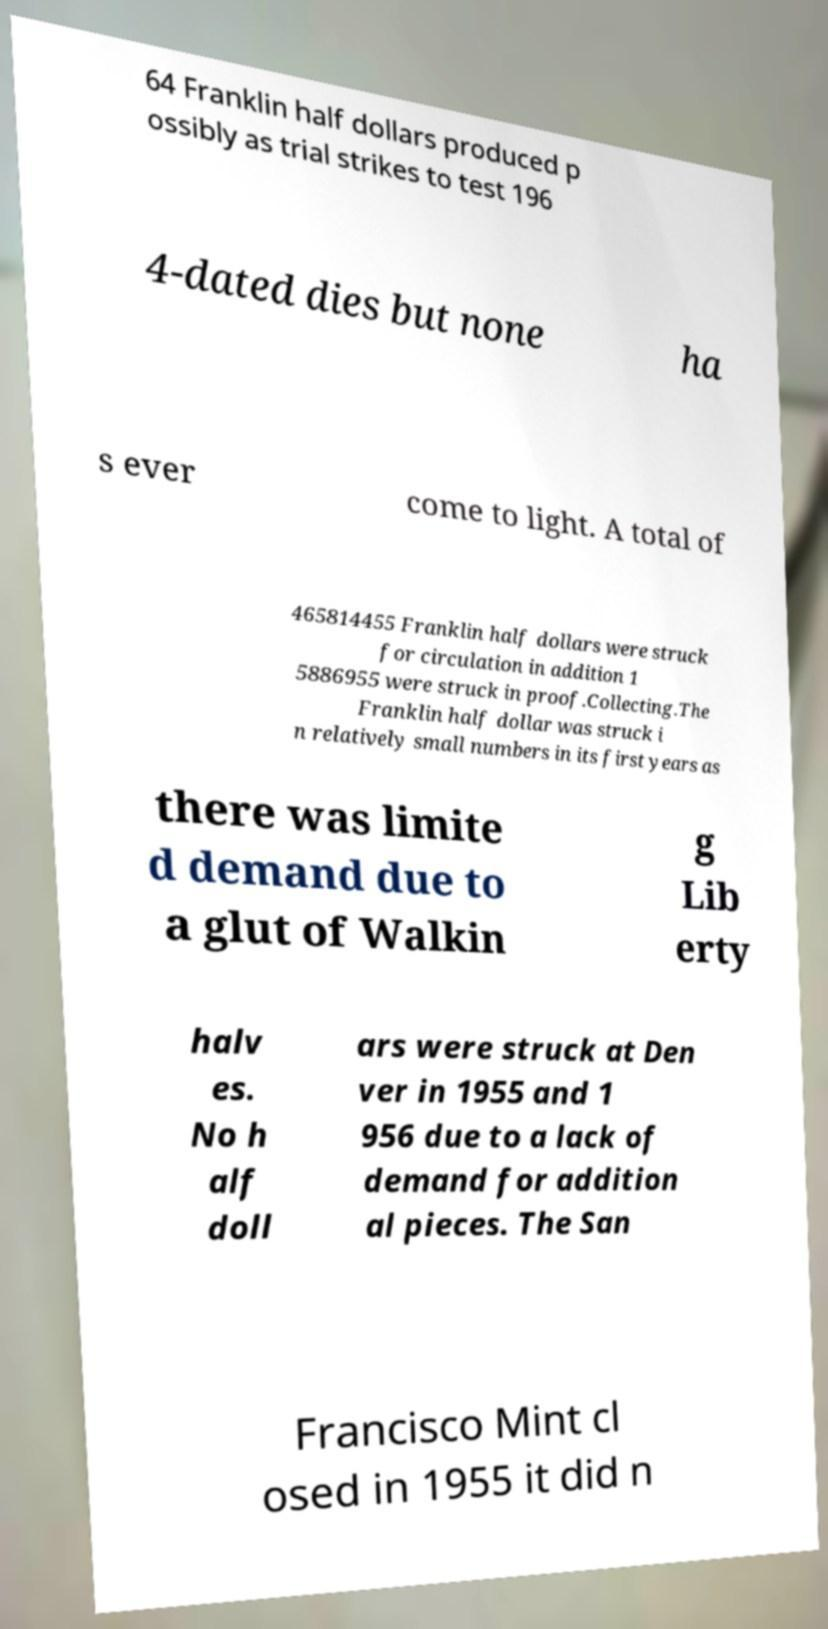Can you accurately transcribe the text from the provided image for me? 64 Franklin half dollars produced p ossibly as trial strikes to test 196 4-dated dies but none ha s ever come to light. A total of 465814455 Franklin half dollars were struck for circulation in addition 1 5886955 were struck in proof.Collecting.The Franklin half dollar was struck i n relatively small numbers in its first years as there was limite d demand due to a glut of Walkin g Lib erty halv es. No h alf doll ars were struck at Den ver in 1955 and 1 956 due to a lack of demand for addition al pieces. The San Francisco Mint cl osed in 1955 it did n 